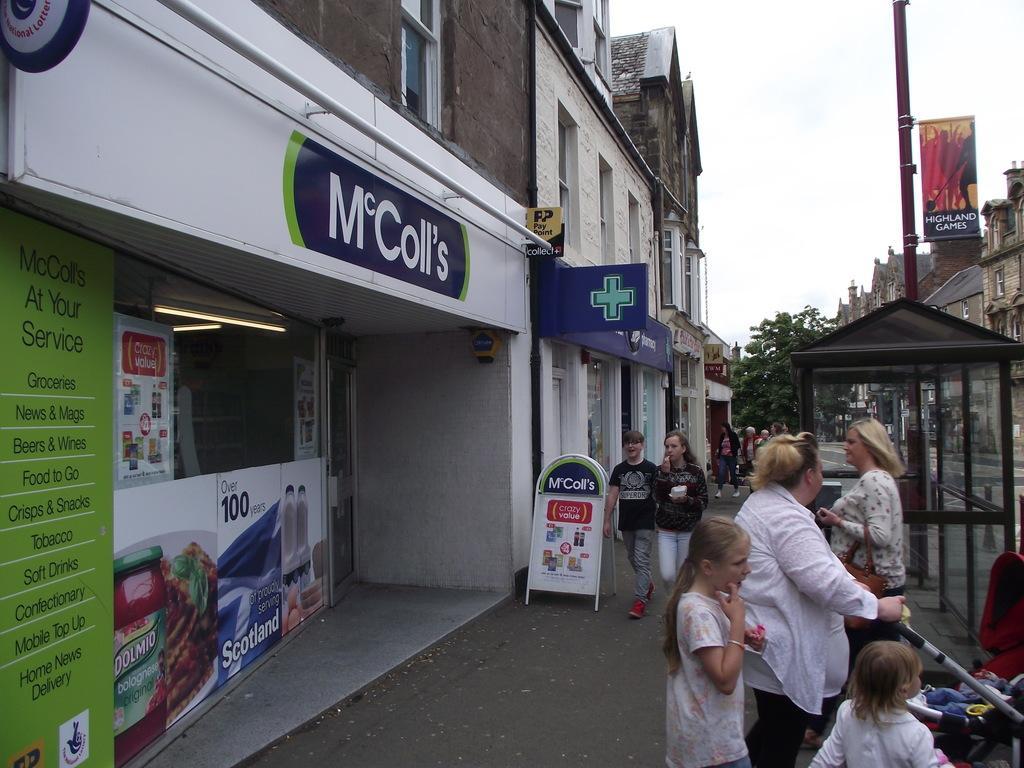Could you give a brief overview of what you see in this image? In this image, we can see people and some are holding some objects and there is a lady wearing a bag. In the background, there are buildings and we can see a pole and there are boards and trees and there are some posters and a booth. At the top, there is sky and at the bottom, there is a road and a trolley. 